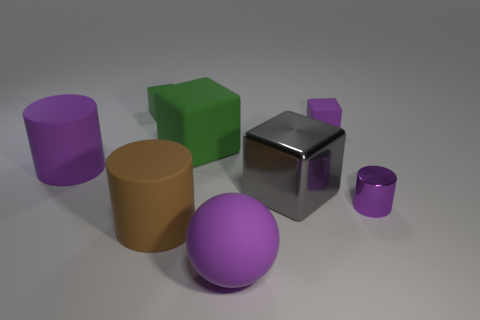How many objects are either spheres that are in front of the large brown rubber object or matte things that are left of the purple rubber block?
Your response must be concise. 5. Are there any small green objects to the left of the small green matte cube?
Provide a succinct answer. No. There is a small rubber object that is on the right side of the green rubber block to the right of the big matte cylinder in front of the tiny purple metal object; what color is it?
Keep it short and to the point. Purple. Is the gray thing the same shape as the small purple metal thing?
Your answer should be very brief. No. What color is the large sphere that is the same material as the large green cube?
Offer a very short reply. Purple. How many objects are either purple rubber objects that are in front of the purple matte block or tiny yellow metallic balls?
Offer a very short reply. 2. What is the size of the purple cylinder that is left of the tiny purple matte thing?
Give a very brief answer. Large. There is a gray metal block; does it have the same size as the green object in front of the small purple matte thing?
Make the answer very short. Yes. What is the color of the large rubber cylinder left of the large rubber cylinder on the right side of the large purple rubber cylinder?
Your answer should be compact. Purple. What number of other objects are there of the same color as the sphere?
Offer a terse response. 3. 